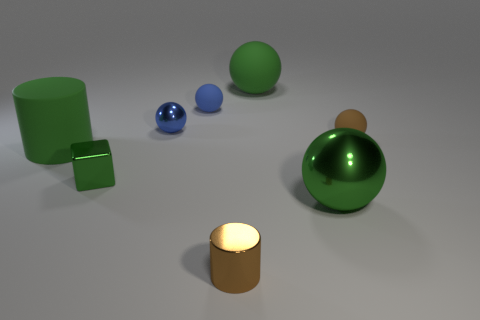What number of other objects are the same color as the small cylinder?
Provide a short and direct response. 1. What number of green things are either small spheres or small objects?
Your answer should be compact. 1. What is the cylinder on the right side of the green cube made of?
Make the answer very short. Metal. Does the brown thing in front of the tiny metal cube have the same material as the large green cylinder?
Your answer should be compact. No. What shape is the blue shiny thing?
Your answer should be very brief. Sphere. What number of small metal things are behind the brown thing left of the green rubber thing to the right of the block?
Provide a succinct answer. 2. How many other things are there of the same material as the small green cube?
Keep it short and to the point. 3. What material is the brown cylinder that is the same size as the green shiny block?
Provide a succinct answer. Metal. There is a tiny matte sphere behind the brown rubber thing; is its color the same as the rubber cylinder that is behind the small shiny cylinder?
Keep it short and to the point. No. Are there any large yellow things of the same shape as the brown metallic thing?
Offer a very short reply. No. 